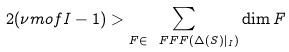Convert formula to latex. <formula><loc_0><loc_0><loc_500><loc_500>2 ( \nu m o f { I } - 1 ) > \sum _ { F \in \ F F F ( \Delta ( S ) | _ { I } ) } \dim F</formula> 